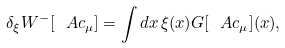Convert formula to latex. <formula><loc_0><loc_0><loc_500><loc_500>\delta _ { \xi } W ^ { - } [ \ A c _ { \mu } ] = \int d x \, \xi ( x ) G [ \ A c _ { \mu } ] ( x ) ,</formula> 